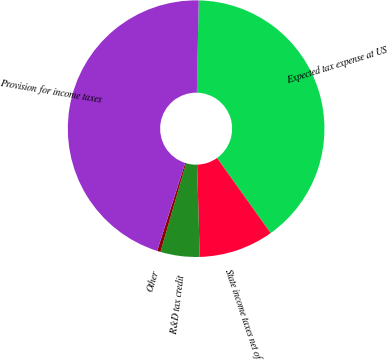Convert chart to OTSL. <chart><loc_0><loc_0><loc_500><loc_500><pie_chart><fcel>Expected tax expense at US<fcel>State income taxes net of<fcel>R&D tax credit<fcel>Other<fcel>Provision for income taxes<nl><fcel>39.82%<fcel>9.42%<fcel>4.93%<fcel>0.43%<fcel>45.41%<nl></chart> 